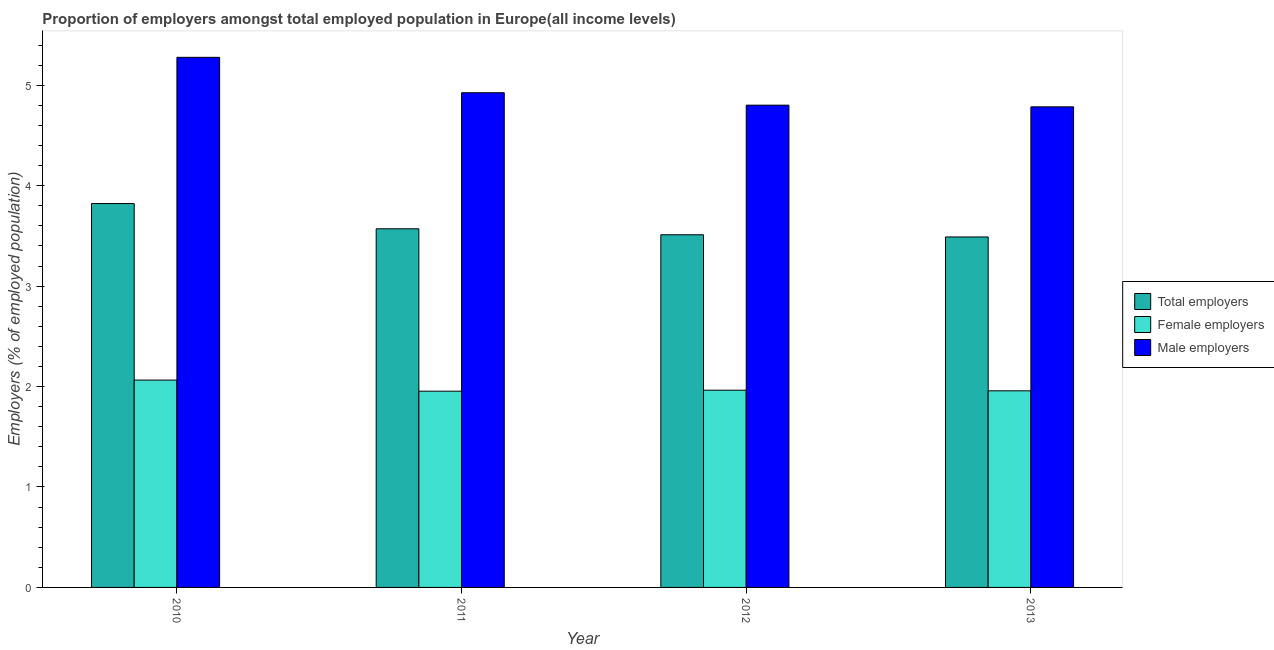Are the number of bars per tick equal to the number of legend labels?
Your answer should be compact. Yes. Are the number of bars on each tick of the X-axis equal?
Provide a succinct answer. Yes. How many bars are there on the 1st tick from the right?
Keep it short and to the point. 3. In how many cases, is the number of bars for a given year not equal to the number of legend labels?
Offer a terse response. 0. What is the percentage of male employers in 2012?
Your response must be concise. 4.8. Across all years, what is the maximum percentage of male employers?
Make the answer very short. 5.28. Across all years, what is the minimum percentage of male employers?
Keep it short and to the point. 4.78. In which year was the percentage of female employers minimum?
Provide a short and direct response. 2011. What is the total percentage of total employers in the graph?
Ensure brevity in your answer.  14.39. What is the difference between the percentage of female employers in 2010 and that in 2013?
Offer a very short reply. 0.11. What is the difference between the percentage of female employers in 2010 and the percentage of male employers in 2011?
Keep it short and to the point. 0.11. What is the average percentage of male employers per year?
Provide a succinct answer. 4.95. In the year 2010, what is the difference between the percentage of female employers and percentage of total employers?
Give a very brief answer. 0. What is the ratio of the percentage of male employers in 2012 to that in 2013?
Offer a terse response. 1. Is the difference between the percentage of total employers in 2012 and 2013 greater than the difference between the percentage of male employers in 2012 and 2013?
Provide a short and direct response. No. What is the difference between the highest and the second highest percentage of male employers?
Keep it short and to the point. 0.35. What is the difference between the highest and the lowest percentage of female employers?
Your answer should be very brief. 0.11. In how many years, is the percentage of total employers greater than the average percentage of total employers taken over all years?
Make the answer very short. 1. What does the 2nd bar from the left in 2010 represents?
Your answer should be very brief. Female employers. What does the 1st bar from the right in 2012 represents?
Keep it short and to the point. Male employers. How many bars are there?
Provide a short and direct response. 12. Are the values on the major ticks of Y-axis written in scientific E-notation?
Offer a terse response. No. Does the graph contain grids?
Provide a short and direct response. No. Where does the legend appear in the graph?
Your answer should be very brief. Center right. What is the title of the graph?
Make the answer very short. Proportion of employers amongst total employed population in Europe(all income levels). What is the label or title of the Y-axis?
Provide a succinct answer. Employers (% of employed population). What is the Employers (% of employed population) of Total employers in 2010?
Give a very brief answer. 3.82. What is the Employers (% of employed population) of Female employers in 2010?
Ensure brevity in your answer.  2.06. What is the Employers (% of employed population) of Male employers in 2010?
Your answer should be very brief. 5.28. What is the Employers (% of employed population) of Total employers in 2011?
Offer a terse response. 3.57. What is the Employers (% of employed population) of Female employers in 2011?
Provide a short and direct response. 1.95. What is the Employers (% of employed population) of Male employers in 2011?
Give a very brief answer. 4.93. What is the Employers (% of employed population) in Total employers in 2012?
Your answer should be compact. 3.51. What is the Employers (% of employed population) in Female employers in 2012?
Provide a short and direct response. 1.96. What is the Employers (% of employed population) of Male employers in 2012?
Offer a very short reply. 4.8. What is the Employers (% of employed population) in Total employers in 2013?
Make the answer very short. 3.49. What is the Employers (% of employed population) in Female employers in 2013?
Provide a succinct answer. 1.96. What is the Employers (% of employed population) of Male employers in 2013?
Provide a short and direct response. 4.78. Across all years, what is the maximum Employers (% of employed population) in Total employers?
Provide a succinct answer. 3.82. Across all years, what is the maximum Employers (% of employed population) in Female employers?
Keep it short and to the point. 2.06. Across all years, what is the maximum Employers (% of employed population) of Male employers?
Give a very brief answer. 5.28. Across all years, what is the minimum Employers (% of employed population) of Total employers?
Give a very brief answer. 3.49. Across all years, what is the minimum Employers (% of employed population) in Female employers?
Your answer should be compact. 1.95. Across all years, what is the minimum Employers (% of employed population) of Male employers?
Give a very brief answer. 4.78. What is the total Employers (% of employed population) in Total employers in the graph?
Provide a short and direct response. 14.39. What is the total Employers (% of employed population) in Female employers in the graph?
Your answer should be very brief. 7.94. What is the total Employers (% of employed population) of Male employers in the graph?
Make the answer very short. 19.79. What is the difference between the Employers (% of employed population) in Total employers in 2010 and that in 2011?
Provide a short and direct response. 0.25. What is the difference between the Employers (% of employed population) in Female employers in 2010 and that in 2011?
Your answer should be compact. 0.11. What is the difference between the Employers (% of employed population) in Male employers in 2010 and that in 2011?
Your response must be concise. 0.35. What is the difference between the Employers (% of employed population) of Total employers in 2010 and that in 2012?
Keep it short and to the point. 0.31. What is the difference between the Employers (% of employed population) of Female employers in 2010 and that in 2012?
Provide a short and direct response. 0.1. What is the difference between the Employers (% of employed population) in Male employers in 2010 and that in 2012?
Provide a succinct answer. 0.48. What is the difference between the Employers (% of employed population) of Total employers in 2010 and that in 2013?
Offer a terse response. 0.33. What is the difference between the Employers (% of employed population) of Female employers in 2010 and that in 2013?
Your answer should be very brief. 0.11. What is the difference between the Employers (% of employed population) of Male employers in 2010 and that in 2013?
Ensure brevity in your answer.  0.49. What is the difference between the Employers (% of employed population) in Total employers in 2011 and that in 2012?
Your response must be concise. 0.06. What is the difference between the Employers (% of employed population) of Female employers in 2011 and that in 2012?
Offer a terse response. -0.01. What is the difference between the Employers (% of employed population) in Male employers in 2011 and that in 2012?
Ensure brevity in your answer.  0.12. What is the difference between the Employers (% of employed population) in Total employers in 2011 and that in 2013?
Ensure brevity in your answer.  0.08. What is the difference between the Employers (% of employed population) of Female employers in 2011 and that in 2013?
Your response must be concise. -0. What is the difference between the Employers (% of employed population) in Male employers in 2011 and that in 2013?
Your answer should be very brief. 0.14. What is the difference between the Employers (% of employed population) in Total employers in 2012 and that in 2013?
Make the answer very short. 0.02. What is the difference between the Employers (% of employed population) of Female employers in 2012 and that in 2013?
Your answer should be very brief. 0.01. What is the difference between the Employers (% of employed population) in Male employers in 2012 and that in 2013?
Offer a very short reply. 0.02. What is the difference between the Employers (% of employed population) of Total employers in 2010 and the Employers (% of employed population) of Female employers in 2011?
Ensure brevity in your answer.  1.87. What is the difference between the Employers (% of employed population) in Total employers in 2010 and the Employers (% of employed population) in Male employers in 2011?
Your answer should be very brief. -1.1. What is the difference between the Employers (% of employed population) in Female employers in 2010 and the Employers (% of employed population) in Male employers in 2011?
Keep it short and to the point. -2.86. What is the difference between the Employers (% of employed population) in Total employers in 2010 and the Employers (% of employed population) in Female employers in 2012?
Ensure brevity in your answer.  1.86. What is the difference between the Employers (% of employed population) in Total employers in 2010 and the Employers (% of employed population) in Male employers in 2012?
Make the answer very short. -0.98. What is the difference between the Employers (% of employed population) in Female employers in 2010 and the Employers (% of employed population) in Male employers in 2012?
Your response must be concise. -2.74. What is the difference between the Employers (% of employed population) in Total employers in 2010 and the Employers (% of employed population) in Female employers in 2013?
Offer a very short reply. 1.86. What is the difference between the Employers (% of employed population) in Total employers in 2010 and the Employers (% of employed population) in Male employers in 2013?
Ensure brevity in your answer.  -0.96. What is the difference between the Employers (% of employed population) in Female employers in 2010 and the Employers (% of employed population) in Male employers in 2013?
Provide a short and direct response. -2.72. What is the difference between the Employers (% of employed population) in Total employers in 2011 and the Employers (% of employed population) in Female employers in 2012?
Make the answer very short. 1.61. What is the difference between the Employers (% of employed population) of Total employers in 2011 and the Employers (% of employed population) of Male employers in 2012?
Keep it short and to the point. -1.23. What is the difference between the Employers (% of employed population) of Female employers in 2011 and the Employers (% of employed population) of Male employers in 2012?
Make the answer very short. -2.85. What is the difference between the Employers (% of employed population) of Total employers in 2011 and the Employers (% of employed population) of Female employers in 2013?
Your answer should be very brief. 1.61. What is the difference between the Employers (% of employed population) of Total employers in 2011 and the Employers (% of employed population) of Male employers in 2013?
Keep it short and to the point. -1.21. What is the difference between the Employers (% of employed population) of Female employers in 2011 and the Employers (% of employed population) of Male employers in 2013?
Your answer should be compact. -2.83. What is the difference between the Employers (% of employed population) in Total employers in 2012 and the Employers (% of employed population) in Female employers in 2013?
Provide a succinct answer. 1.55. What is the difference between the Employers (% of employed population) of Total employers in 2012 and the Employers (% of employed population) of Male employers in 2013?
Make the answer very short. -1.27. What is the difference between the Employers (% of employed population) of Female employers in 2012 and the Employers (% of employed population) of Male employers in 2013?
Keep it short and to the point. -2.82. What is the average Employers (% of employed population) of Total employers per year?
Provide a succinct answer. 3.6. What is the average Employers (% of employed population) in Female employers per year?
Provide a succinct answer. 1.98. What is the average Employers (% of employed population) of Male employers per year?
Keep it short and to the point. 4.95. In the year 2010, what is the difference between the Employers (% of employed population) of Total employers and Employers (% of employed population) of Female employers?
Make the answer very short. 1.76. In the year 2010, what is the difference between the Employers (% of employed population) of Total employers and Employers (% of employed population) of Male employers?
Offer a very short reply. -1.46. In the year 2010, what is the difference between the Employers (% of employed population) in Female employers and Employers (% of employed population) in Male employers?
Keep it short and to the point. -3.21. In the year 2011, what is the difference between the Employers (% of employed population) of Total employers and Employers (% of employed population) of Female employers?
Ensure brevity in your answer.  1.62. In the year 2011, what is the difference between the Employers (% of employed population) of Total employers and Employers (% of employed population) of Male employers?
Make the answer very short. -1.35. In the year 2011, what is the difference between the Employers (% of employed population) in Female employers and Employers (% of employed population) in Male employers?
Offer a terse response. -2.97. In the year 2012, what is the difference between the Employers (% of employed population) in Total employers and Employers (% of employed population) in Female employers?
Give a very brief answer. 1.55. In the year 2012, what is the difference between the Employers (% of employed population) in Total employers and Employers (% of employed population) in Male employers?
Offer a very short reply. -1.29. In the year 2012, what is the difference between the Employers (% of employed population) in Female employers and Employers (% of employed population) in Male employers?
Your answer should be very brief. -2.84. In the year 2013, what is the difference between the Employers (% of employed population) of Total employers and Employers (% of employed population) of Female employers?
Provide a succinct answer. 1.53. In the year 2013, what is the difference between the Employers (% of employed population) in Total employers and Employers (% of employed population) in Male employers?
Your answer should be compact. -1.3. In the year 2013, what is the difference between the Employers (% of employed population) of Female employers and Employers (% of employed population) of Male employers?
Keep it short and to the point. -2.83. What is the ratio of the Employers (% of employed population) of Total employers in 2010 to that in 2011?
Offer a terse response. 1.07. What is the ratio of the Employers (% of employed population) of Female employers in 2010 to that in 2011?
Keep it short and to the point. 1.06. What is the ratio of the Employers (% of employed population) in Male employers in 2010 to that in 2011?
Provide a short and direct response. 1.07. What is the ratio of the Employers (% of employed population) in Total employers in 2010 to that in 2012?
Your answer should be very brief. 1.09. What is the ratio of the Employers (% of employed population) of Female employers in 2010 to that in 2012?
Your answer should be very brief. 1.05. What is the ratio of the Employers (% of employed population) of Male employers in 2010 to that in 2012?
Ensure brevity in your answer.  1.1. What is the ratio of the Employers (% of employed population) in Total employers in 2010 to that in 2013?
Your answer should be compact. 1.1. What is the ratio of the Employers (% of employed population) in Female employers in 2010 to that in 2013?
Provide a succinct answer. 1.05. What is the ratio of the Employers (% of employed population) in Male employers in 2010 to that in 2013?
Make the answer very short. 1.1. What is the ratio of the Employers (% of employed population) in Female employers in 2011 to that in 2012?
Keep it short and to the point. 0.99. What is the ratio of the Employers (% of employed population) in Male employers in 2011 to that in 2012?
Offer a terse response. 1.03. What is the ratio of the Employers (% of employed population) of Total employers in 2011 to that in 2013?
Ensure brevity in your answer.  1.02. What is the ratio of the Employers (% of employed population) of Male employers in 2011 to that in 2013?
Offer a terse response. 1.03. What is the ratio of the Employers (% of employed population) of Total employers in 2012 to that in 2013?
Your response must be concise. 1.01. What is the ratio of the Employers (% of employed population) of Female employers in 2012 to that in 2013?
Make the answer very short. 1. What is the ratio of the Employers (% of employed population) of Male employers in 2012 to that in 2013?
Your answer should be compact. 1. What is the difference between the highest and the second highest Employers (% of employed population) in Total employers?
Your answer should be compact. 0.25. What is the difference between the highest and the second highest Employers (% of employed population) of Female employers?
Provide a succinct answer. 0.1. What is the difference between the highest and the second highest Employers (% of employed population) of Male employers?
Your answer should be compact. 0.35. What is the difference between the highest and the lowest Employers (% of employed population) in Total employers?
Your answer should be very brief. 0.33. What is the difference between the highest and the lowest Employers (% of employed population) in Female employers?
Your answer should be very brief. 0.11. What is the difference between the highest and the lowest Employers (% of employed population) of Male employers?
Provide a succinct answer. 0.49. 